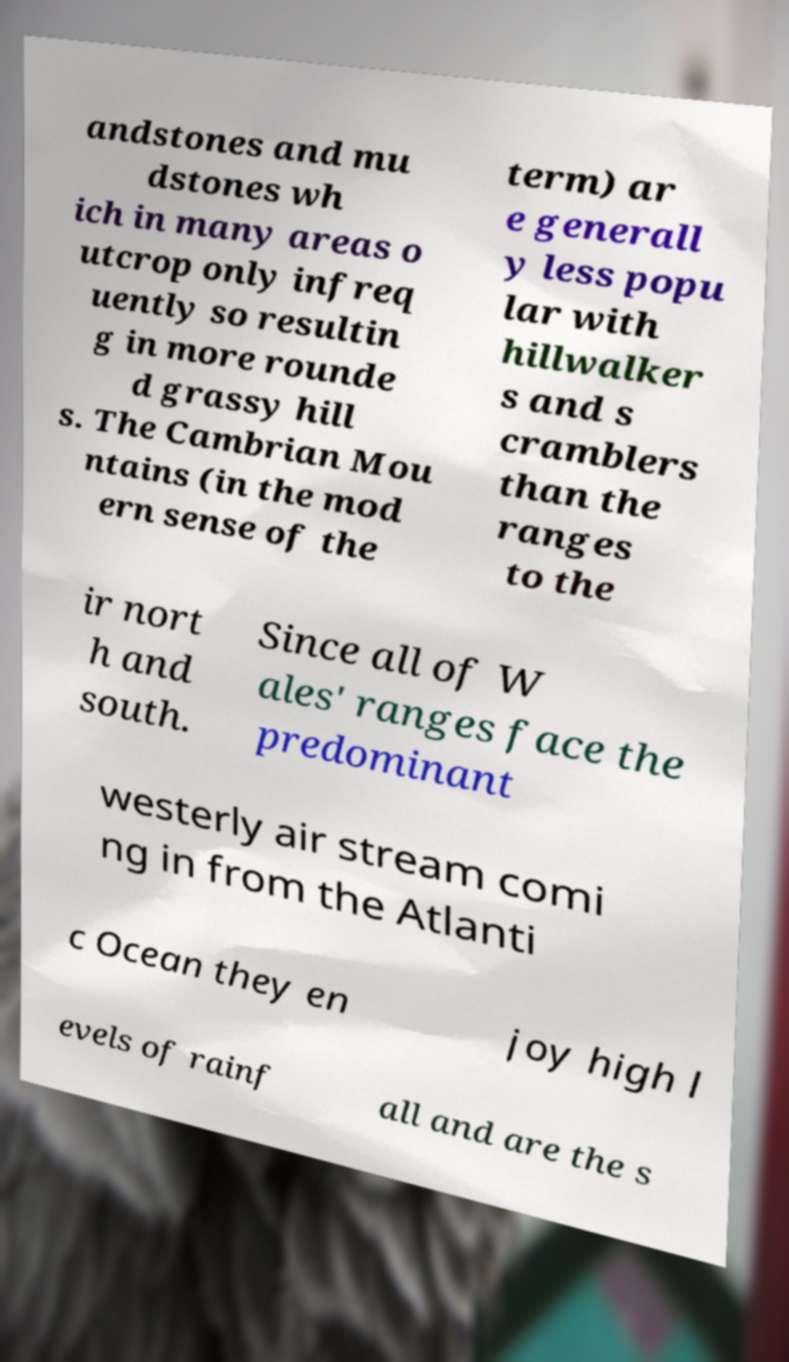Can you read and provide the text displayed in the image?This photo seems to have some interesting text. Can you extract and type it out for me? andstones and mu dstones wh ich in many areas o utcrop only infreq uently so resultin g in more rounde d grassy hill s. The Cambrian Mou ntains (in the mod ern sense of the term) ar e generall y less popu lar with hillwalker s and s cramblers than the ranges to the ir nort h and south. Since all of W ales' ranges face the predominant westerly air stream comi ng in from the Atlanti c Ocean they en joy high l evels of rainf all and are the s 